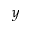Convert formula to latex. <formula><loc_0><loc_0><loc_500><loc_500>y</formula> 